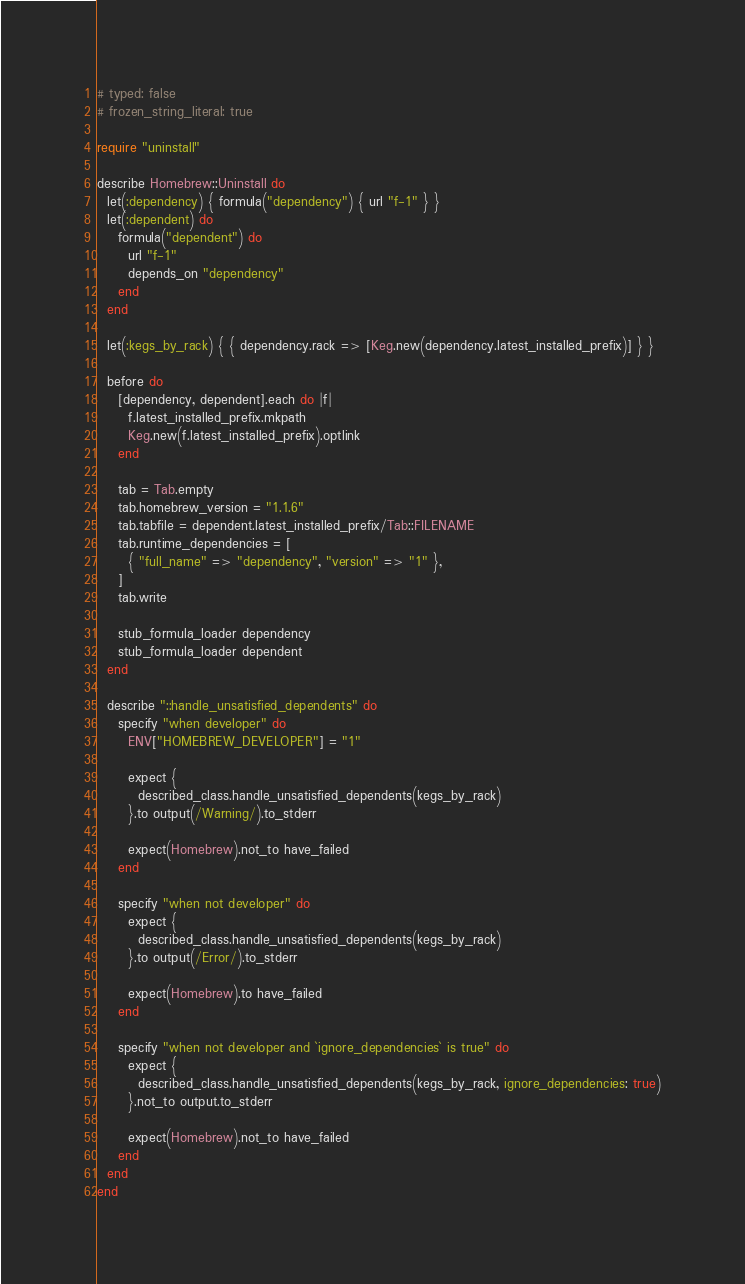Convert code to text. <code><loc_0><loc_0><loc_500><loc_500><_Ruby_># typed: false
# frozen_string_literal: true

require "uninstall"

describe Homebrew::Uninstall do
  let(:dependency) { formula("dependency") { url "f-1" } }
  let(:dependent) do
    formula("dependent") do
      url "f-1"
      depends_on "dependency"
    end
  end

  let(:kegs_by_rack) { { dependency.rack => [Keg.new(dependency.latest_installed_prefix)] } }

  before do
    [dependency, dependent].each do |f|
      f.latest_installed_prefix.mkpath
      Keg.new(f.latest_installed_prefix).optlink
    end

    tab = Tab.empty
    tab.homebrew_version = "1.1.6"
    tab.tabfile = dependent.latest_installed_prefix/Tab::FILENAME
    tab.runtime_dependencies = [
      { "full_name" => "dependency", "version" => "1" },
    ]
    tab.write

    stub_formula_loader dependency
    stub_formula_loader dependent
  end

  describe "::handle_unsatisfied_dependents" do
    specify "when developer" do
      ENV["HOMEBREW_DEVELOPER"] = "1"

      expect {
        described_class.handle_unsatisfied_dependents(kegs_by_rack)
      }.to output(/Warning/).to_stderr

      expect(Homebrew).not_to have_failed
    end

    specify "when not developer" do
      expect {
        described_class.handle_unsatisfied_dependents(kegs_by_rack)
      }.to output(/Error/).to_stderr

      expect(Homebrew).to have_failed
    end

    specify "when not developer and `ignore_dependencies` is true" do
      expect {
        described_class.handle_unsatisfied_dependents(kegs_by_rack, ignore_dependencies: true)
      }.not_to output.to_stderr

      expect(Homebrew).not_to have_failed
    end
  end
end
</code> 